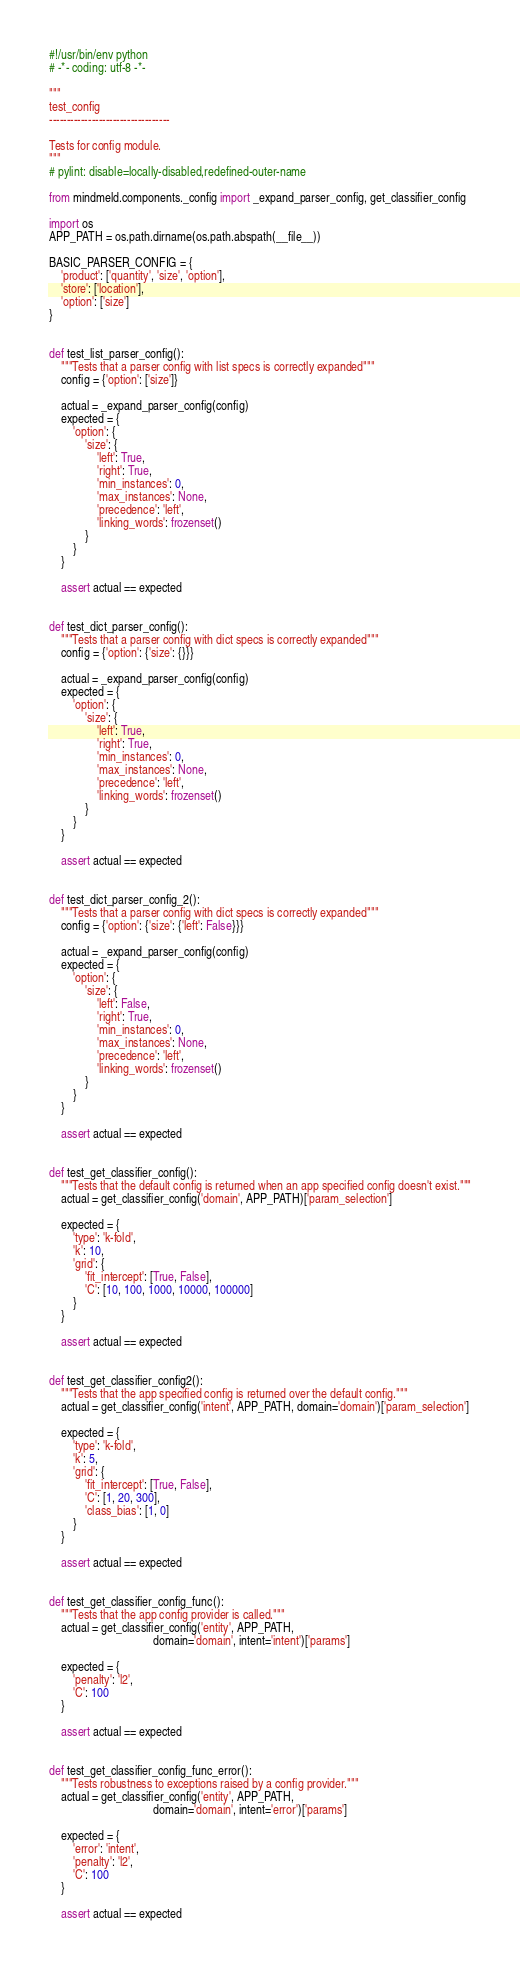<code> <loc_0><loc_0><loc_500><loc_500><_Python_>#!/usr/bin/env python
# -*- coding: utf-8 -*-

"""
test_config
----------------------------------

Tests for config module.
"""
# pylint: disable=locally-disabled,redefined-outer-name

from mindmeld.components._config import _expand_parser_config, get_classifier_config

import os
APP_PATH = os.path.dirname(os.path.abspath(__file__))

BASIC_PARSER_CONFIG = {
    'product': ['quantity', 'size', 'option'],
    'store': ['location'],
    'option': ['size']
}


def test_list_parser_config():
    """Tests that a parser config with list specs is correctly expanded"""
    config = {'option': ['size']}

    actual = _expand_parser_config(config)
    expected = {
        'option': {
            'size': {
                'left': True,
                'right': True,
                'min_instances': 0,
                'max_instances': None,
                'precedence': 'left',
                'linking_words': frozenset()
            }
        }
    }

    assert actual == expected


def test_dict_parser_config():
    """Tests that a parser config with dict specs is correctly expanded"""
    config = {'option': {'size': {}}}

    actual = _expand_parser_config(config)
    expected = {
        'option': {
            'size': {
                'left': True,
                'right': True,
                'min_instances': 0,
                'max_instances': None,
                'precedence': 'left',
                'linking_words': frozenset()
            }
        }
    }

    assert actual == expected


def test_dict_parser_config_2():
    """Tests that a parser config with dict specs is correctly expanded"""
    config = {'option': {'size': {'left': False}}}

    actual = _expand_parser_config(config)
    expected = {
        'option': {
            'size': {
                'left': False,
                'right': True,
                'min_instances': 0,
                'max_instances': None,
                'precedence': 'left',
                'linking_words': frozenset()
            }
        }
    }

    assert actual == expected


def test_get_classifier_config():
    """Tests that the default config is returned when an app specified config doesn't exist."""
    actual = get_classifier_config('domain', APP_PATH)['param_selection']

    expected = {
        'type': 'k-fold',
        'k': 10,
        'grid': {
            'fit_intercept': [True, False],
            'C': [10, 100, 1000, 10000, 100000]
        }
    }

    assert actual == expected


def test_get_classifier_config2():
    """Tests that the app specified config is returned over the default config."""
    actual = get_classifier_config('intent', APP_PATH, domain='domain')['param_selection']

    expected = {
        'type': 'k-fold',
        'k': 5,
        'grid': {
            'fit_intercept': [True, False],
            'C': [1, 20, 300],
            'class_bias': [1, 0]
        }
    }

    assert actual == expected


def test_get_classifier_config_func():
    """Tests that the app config provider is called."""
    actual = get_classifier_config('entity', APP_PATH,
                                   domain='domain', intent='intent')['params']

    expected = {
        'penalty': 'l2',
        'C': 100
    }

    assert actual == expected


def test_get_classifier_config_func_error():
    """Tests robustness to exceptions raised by a config provider."""
    actual = get_classifier_config('entity', APP_PATH,
                                   domain='domain', intent='error')['params']

    expected = {
        'error': 'intent',
        'penalty': 'l2',
        'C': 100
    }

    assert actual == expected
</code> 